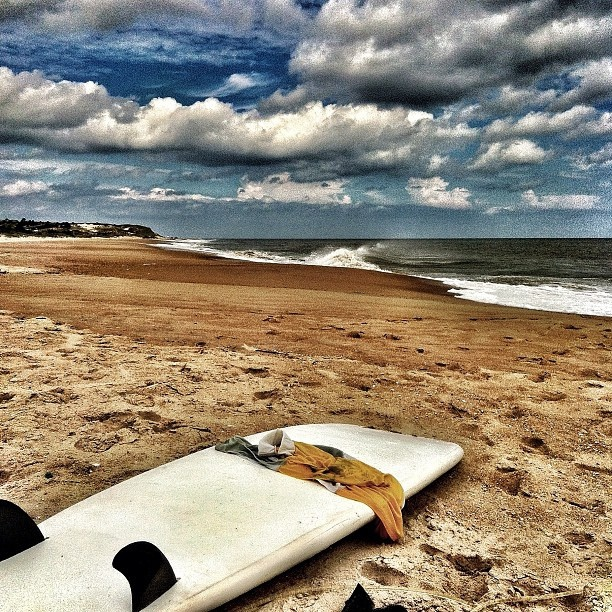Describe the objects in this image and their specific colors. I can see a surfboard in darkgray, beige, and black tones in this image. 